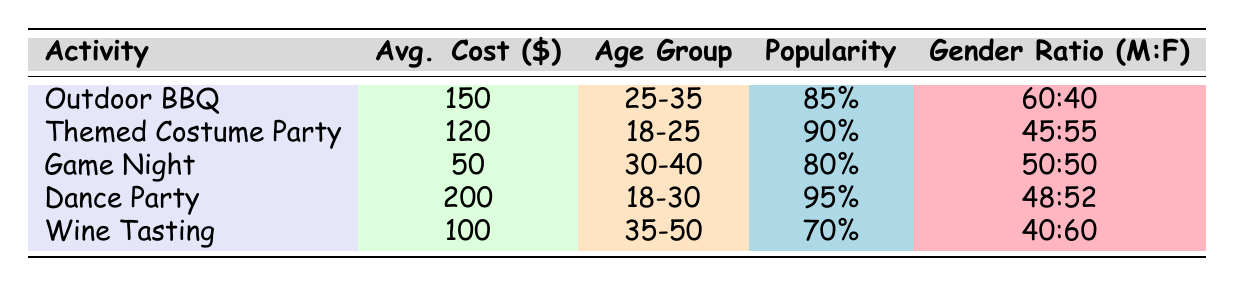What is the average cost of hosting a Dance Party? The table indicates that the Dance Party has an average cost of 200 dollars.
Answer: 200 Which activity has the highest popularity rating? The Dance Party has a popularity rating of 95%, which is the highest among all activities listed in the table.
Answer: Dance Party Is the predominant age group for Outdoor BBQ the same as for Wine Tasting? The Outdoor BBQ is preferred by the 25-35 age group while Wine Tasting is mostly attended by the 35-50 age group. Since these are different age groups, the answer is no.
Answer: No How much more expensive is a Dance Party compared to a Game Night? The cost of a Dance Party is 200 dollars and a Game Night costs 50 dollars. The difference is 200 - 50 = 150 dollars.
Answer: 150 What percentage of attendees at the Themed Costume Party are female? The Gender Ratio for the Themed Costume Party is 45% male and 55% female, indicating that 55% of the attendees are female.
Answer: 55% Does the Game Night have a popularity rating of more than 80%? The Game Night has a popularity rating of 80%, which does not exceed 80%. Therefore, the answer is no.
Answer: No What is the average gender ratio (male to female) across all listed activities? To find the average, we need to convert each gender ratio to a single value: Outdoor BBQ (60:40), Themed Costume Party (45:55), Game Night (50:50), Dance Party (48:52), Wine Tasting (40:60). Converting these ratios gives us: 60% male (0.6), 45% male (0.45), 50% male (0.5), 48% male (0.48), and 40% male (0.4). The average male percentage is (0.6 + 0.45 + 0.5 + 0.48 + 0.4) / 5 = 0.486, or 48.6%. The average ratio is approximately 49:51 (male to female).
Answer: 49:51 Which activity has the lowest average cost? The Game Night has the lowest average cost of 50 dollars, as compared to all other activities listed in the table.
Answer: Game Night Are couples a common attendee group for the Dance Party? The common attendees for the Dance Party listed in the table are Young Adults and Friends. Since Couples are not included, the answer is no.
Answer: No 